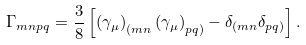<formula> <loc_0><loc_0><loc_500><loc_500>\Gamma _ { m n p q } = { \frac { 3 } { 8 } } \left [ \left ( \gamma _ { \mu } \right ) _ { ( m n } \left ( \gamma _ { \mu } \right ) _ { p q ) } - \delta _ { ( m n } \delta _ { p q ) } \right ] .</formula> 